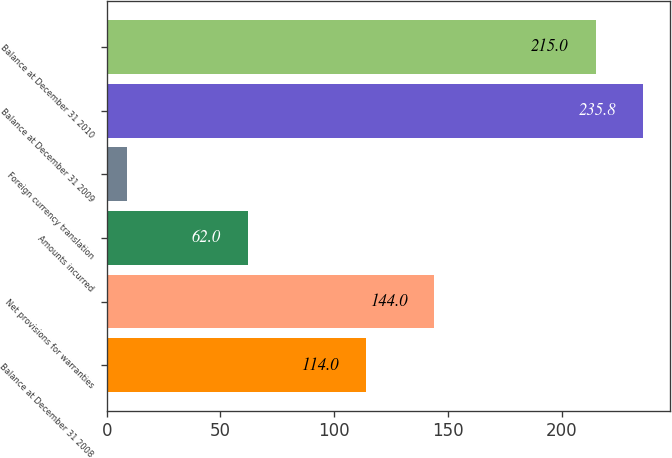<chart> <loc_0><loc_0><loc_500><loc_500><bar_chart><fcel>Balance at December 31 2008<fcel>Net provisions for warranties<fcel>Amounts incurred<fcel>Foreign currency translation<fcel>Balance at December 31 2009<fcel>Balance at December 31 2010<nl><fcel>114<fcel>144<fcel>62<fcel>9<fcel>235.8<fcel>215<nl></chart> 